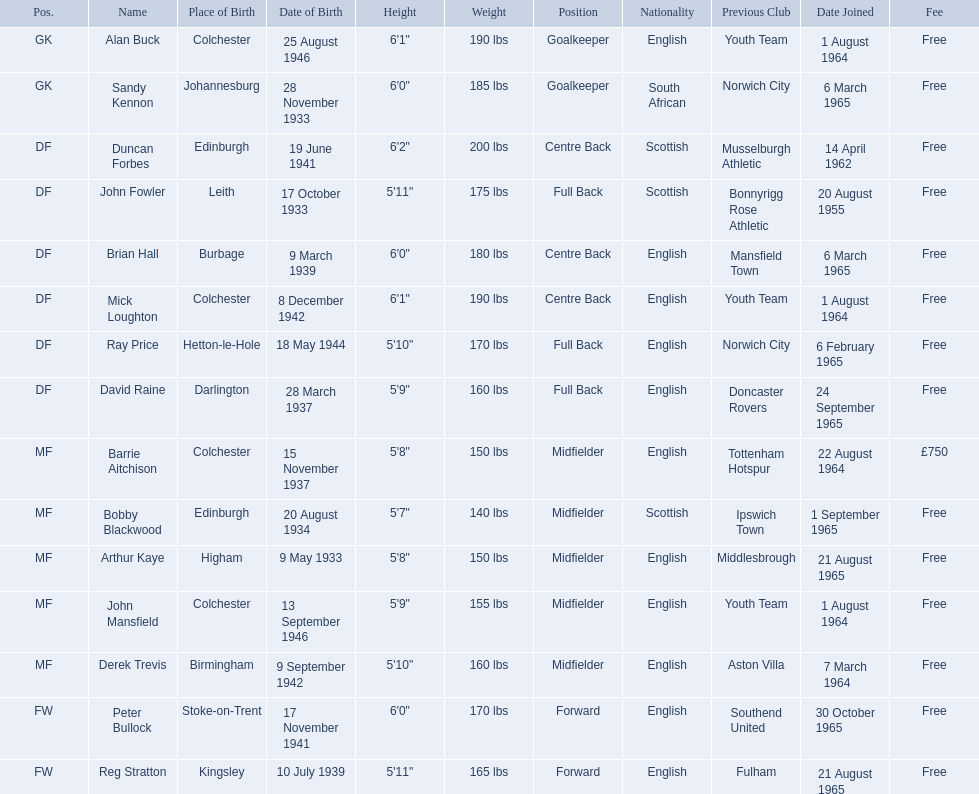Who are all the players? Alan Buck, Sandy Kennon, Duncan Forbes, John Fowler, Brian Hall, Mick Loughton, Ray Price, David Raine, Barrie Aitchison, Bobby Blackwood, Arthur Kaye, John Mansfield, Derek Trevis, Peter Bullock, Reg Stratton. What dates did the players join on? 1 August 1964, 6 March 1965, 14 April 1962, 20 August 1955, 6 March 1965, 1 August 1964, 6 February 1965, 24 September 1965, 22 August 1964, 1 September 1965, 21 August 1965, 1 August 1964, 7 March 1964, 30 October 1965, 21 August 1965. Who is the first player who joined? John Fowler. What is the date of the first person who joined? 20 August 1955. 